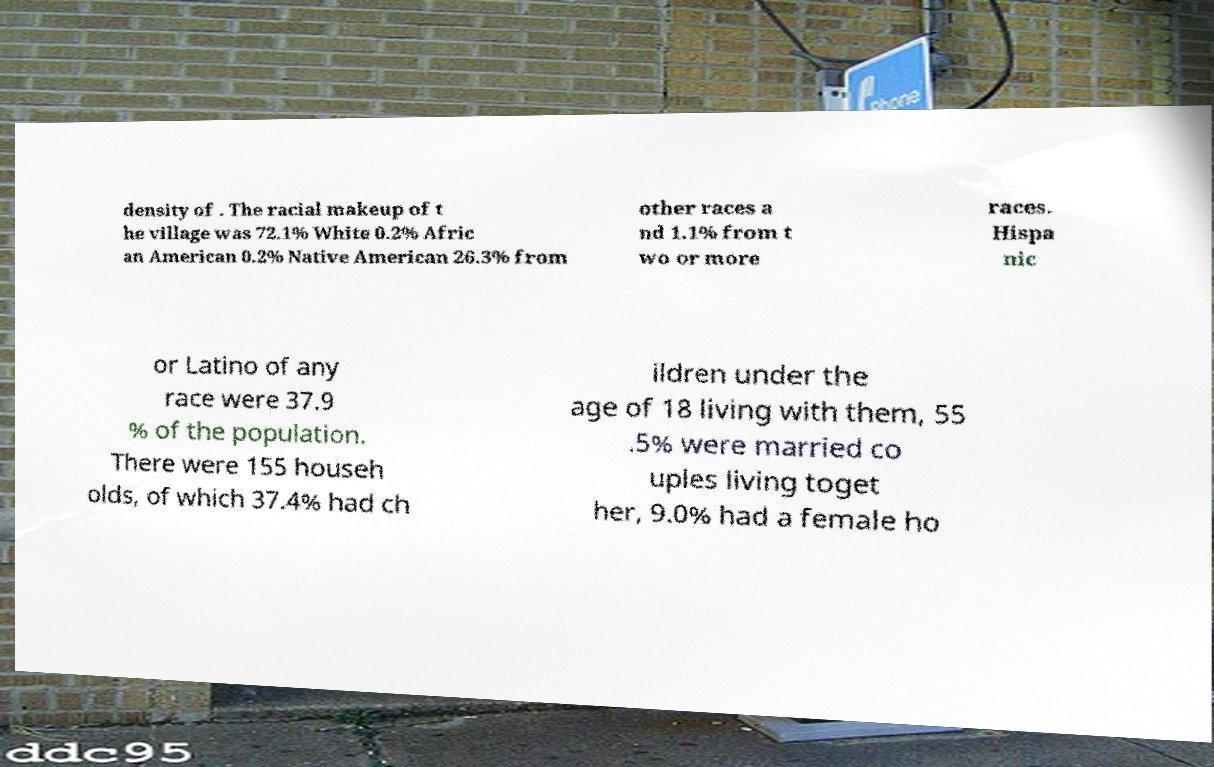There's text embedded in this image that I need extracted. Can you transcribe it verbatim? density of . The racial makeup of t he village was 72.1% White 0.2% Afric an American 0.2% Native American 26.3% from other races a nd 1.1% from t wo or more races. Hispa nic or Latino of any race were 37.9 % of the population. There were 155 househ olds, of which 37.4% had ch ildren under the age of 18 living with them, 55 .5% were married co uples living toget her, 9.0% had a female ho 